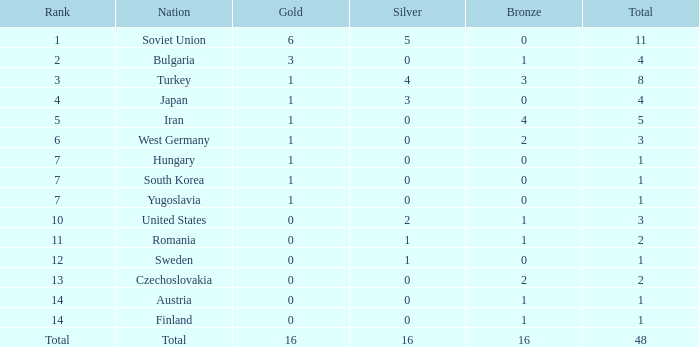How many gold medals do teams hold when the total number of medals is below 1? None. 